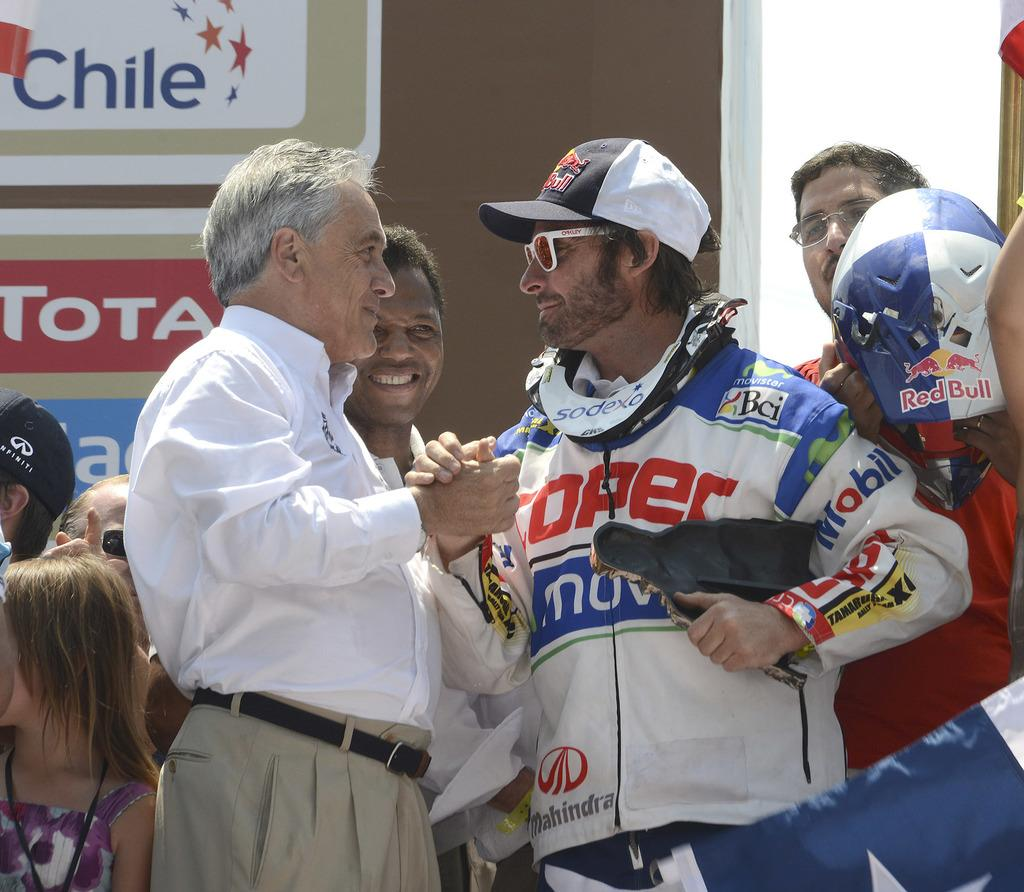<image>
Share a concise interpretation of the image provided. Two men shake hands in front oa sign that reads Chile. 